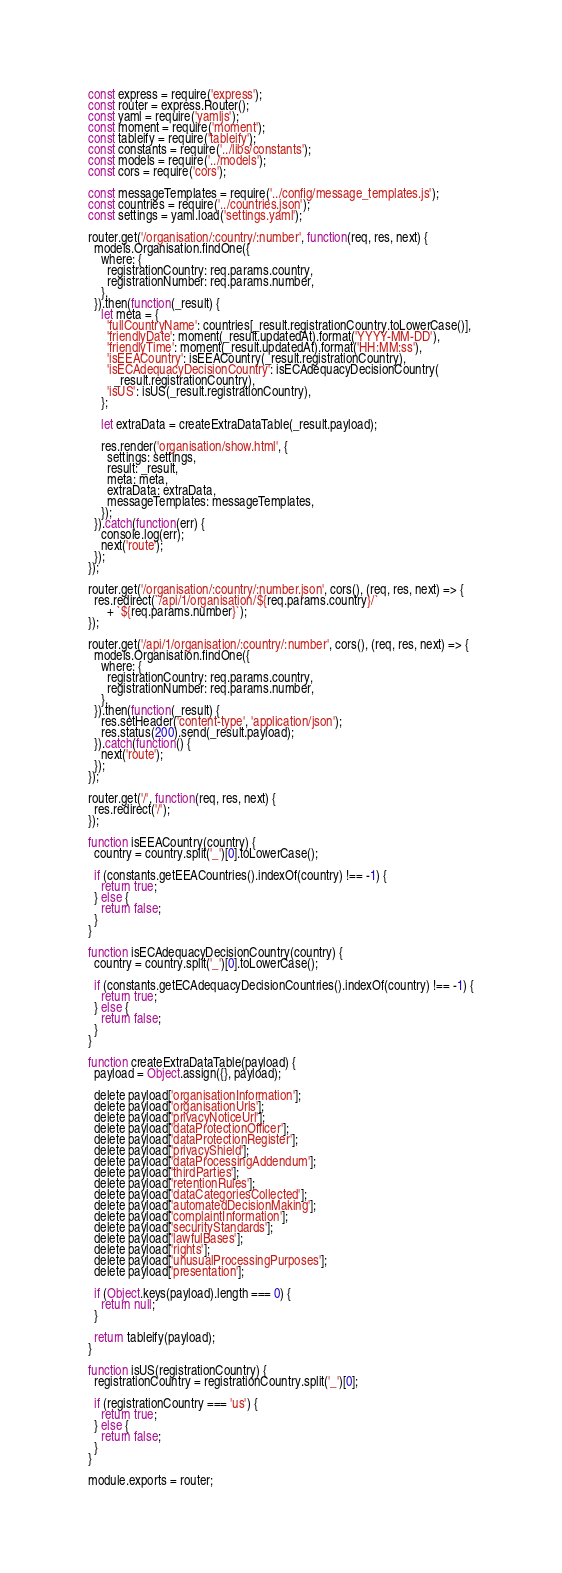Convert code to text. <code><loc_0><loc_0><loc_500><loc_500><_JavaScript_>const express = require('express');
const router = express.Router();
const yaml = require('yamljs');
const moment = require('moment');
const tableify = require('tableify');
const constants = require('../libs/constants');
const models = require('../models');
const cors = require('cors');

const messageTemplates = require('../config/message_templates.js');
const countries = require('../countries.json');
const settings = yaml.load('settings.yaml');

router.get('/organisation/:country/:number', function(req, res, next) {
  models.Organisation.findOne({
    where: {
      registrationCountry: req.params.country,
      registrationNumber: req.params.number,
    },
  }).then(function(_result) {
    let meta = {
      'fullCountryName': countries[_result.registrationCountry.toLowerCase()],
      'friendlyDate': moment(_result.updatedAt).format('YYYY-MM-DD'),
      'friendlyTime': moment(_result.updatedAt).format('HH:MM:ss'),
      'isEEACountry': isEEACountry(_result.registrationCountry),
      'isECAdequacyDecisionCountry': isECAdequacyDecisionCountry(
        _result.registrationCountry),
      'isUS': isUS(_result.registrationCountry),
    };

    let extraData = createExtraDataTable(_result.payload);

    res.render('organisation/show.html', {
      settings: settings,
      result: _result,
      meta: meta,
      extraData: extraData,
      messageTemplates: messageTemplates,
    });
  }).catch(function(err) {
    console.log(err);
    next('route');
  });
});

router.get('/organisation/:country/:number.json', cors(), (req, res, next) => {
  res.redirect(`/api/1/organisation/${req.params.country}/`
      + `${req.params.number}`);
});

router.get('/api/1/organisation/:country/:number', cors(), (req, res, next) => {
  models.Organisation.findOne({
    where: {
      registrationCountry: req.params.country,
      registrationNumber: req.params.number,
    },
  }).then(function(_result) {
    res.setHeader('content-type', 'application/json');
    res.status(200).send(_result.payload);
  }).catch(function() {
    next('route');
  });
});

router.get('/', function(req, res, next) {
  res.redirect('/');
});

function isEEACountry(country) {
  country = country.split('_')[0].toLowerCase();

  if (constants.getEEACountries().indexOf(country) !== -1) {
    return true;
  } else {
    return false;
  }
}

function isECAdequacyDecisionCountry(country) {
  country = country.split('_')[0].toLowerCase();

  if (constants.getECAdequacyDecisionCountries().indexOf(country) !== -1) {
    return true;
  } else {
    return false;
  }
}

function createExtraDataTable(payload) {
  payload = Object.assign({}, payload);

  delete payload['organisationInformation'];
  delete payload['organisationUrls'];
  delete payload['privacyNoticeUrl'];
  delete payload['dataProtectionOfficer'];
  delete payload['dataProtectionRegister'];
  delete payload['privacyShield'];
  delete payload['dataProcessingAddendum'];
  delete payload['thirdParties'];
  delete payload['retentionRules'];
  delete payload['dataCategoriesCollected'];
  delete payload['automatedDecisionMaking'];
  delete payload['complaintInformation'];
  delete payload['securityStandards'];
  delete payload['lawfulBases'];
  delete payload['rights'];
  delete payload['unusualProcessingPurposes'];
  delete payload['presentation'];

  if (Object.keys(payload).length === 0) {
    return null;
  }

  return tableify(payload);
}

function isUS(registrationCountry) {
  registrationCountry = registrationCountry.split('_')[0];

  if (registrationCountry === 'us') {
    return true;
  } else {
    return false;
  }
}

module.exports = router;
</code> 